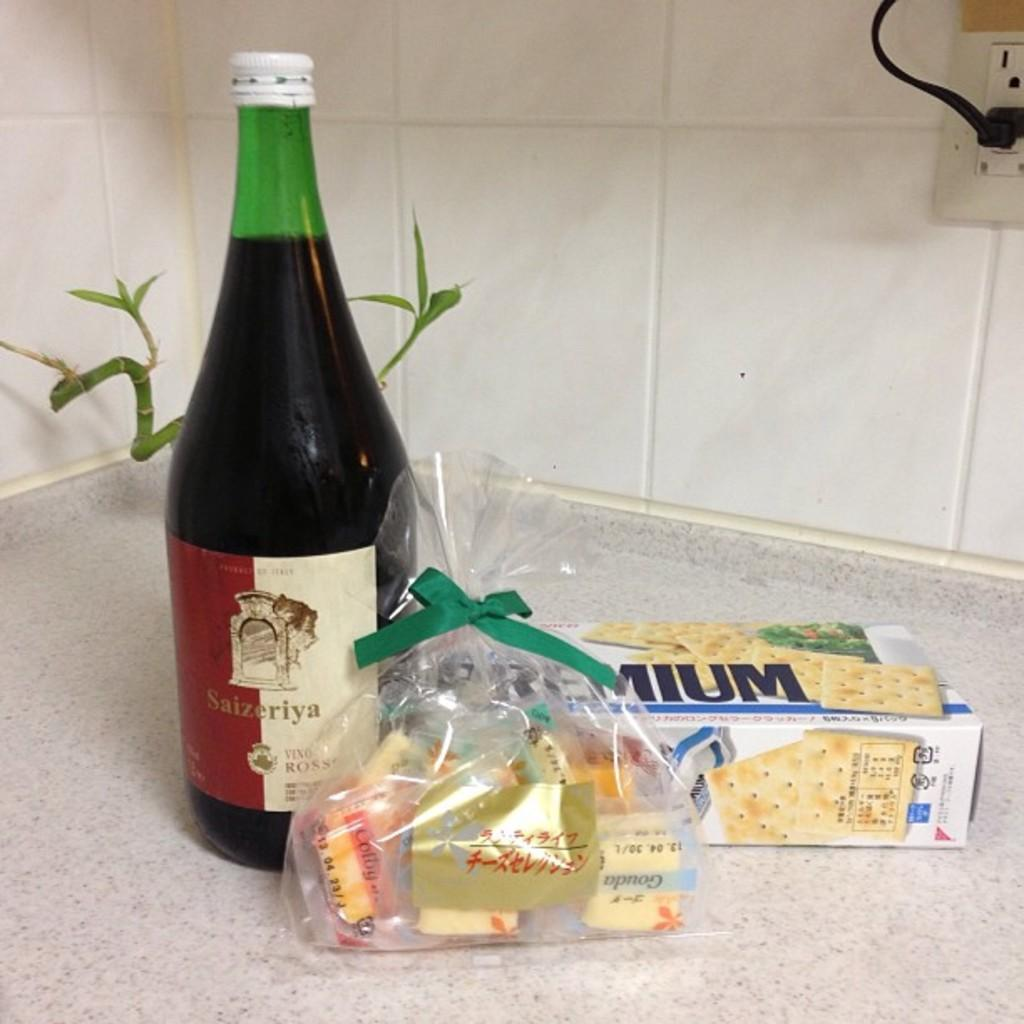<image>
Offer a succinct explanation of the picture presented. Bottle of wine that says "Saizeriya" on a counter by some crackers. 